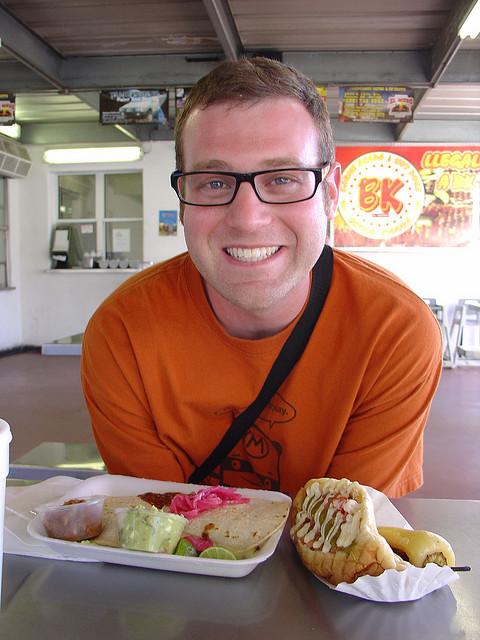Does this man have a beard?
Keep it brief. No. Where is localized the TV?
Quick response, please. On ceiling. Is this man preparing food?
Keep it brief. No. What color is the shirt?
Quick response, please. Orange. Is the man outside?
Quick response, please. Yes. Is this pizza?
Quick response, please. No. Is he wearing glasses?
Quick response, please. Yes. Is the red stuff tomato sauce?
Keep it brief. No. How many lights are in this picture?
Quick response, please. 3. Why is the man smiling at the sandwich?
Answer briefly. Hungry. What is the man Eating?
Answer briefly. Food. How many people are looking at the camera?
Answer briefly. 1. 